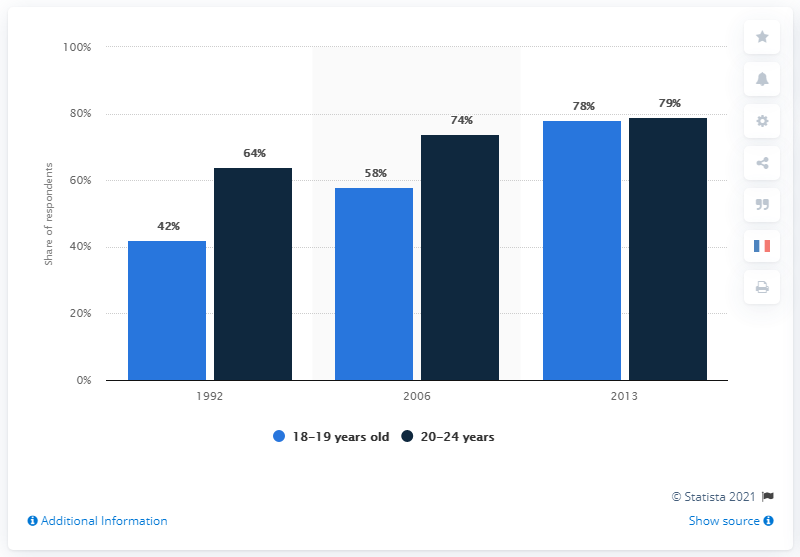Outline some significant characteristics in this image. In the year 1992, the age group with the highest share was 20-24 years old. In the year 1992, there was a significant difference between the two categories. 